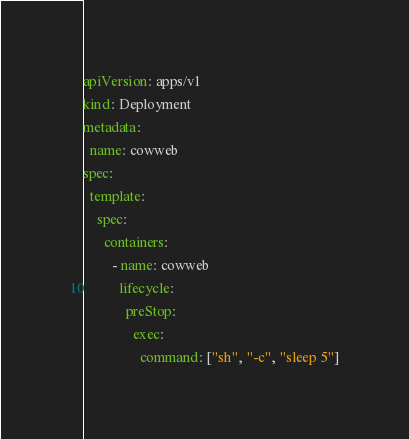Convert code to text. <code><loc_0><loc_0><loc_500><loc_500><_YAML_>apiVersion: apps/v1
kind: Deployment
metadata:
  name: cowweb
spec:
  template:
    spec:
      containers:
        - name: cowweb
          lifecycle:
            preStop:
              exec:
                command: ["sh", "-c", "sleep 5"]</code> 